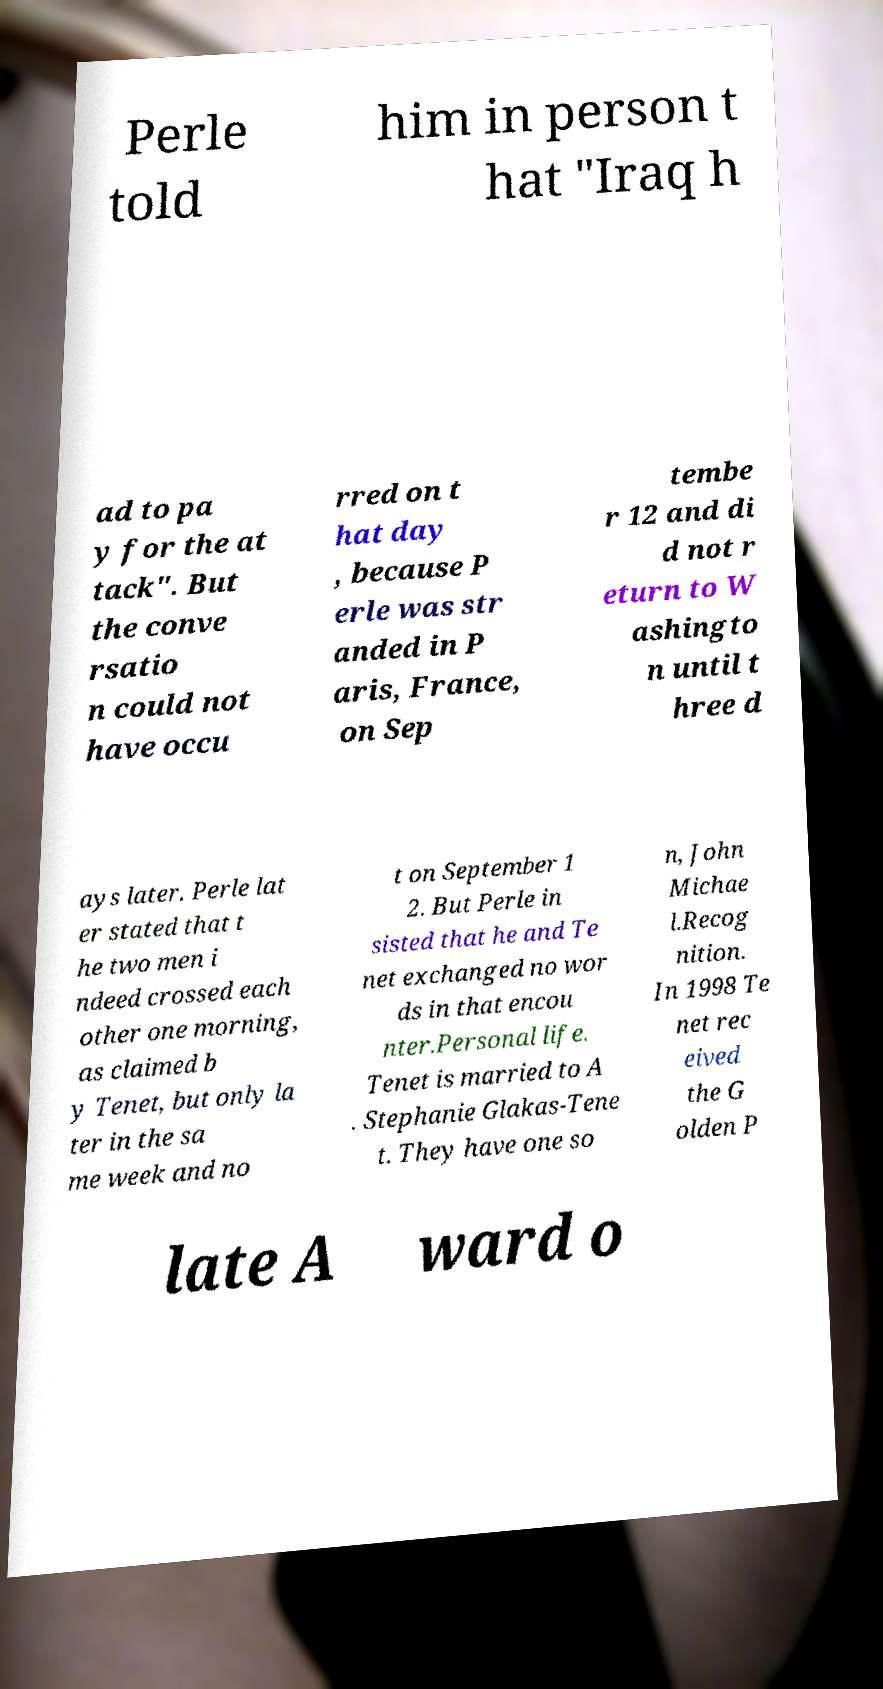Can you read and provide the text displayed in the image?This photo seems to have some interesting text. Can you extract and type it out for me? Perle told him in person t hat "Iraq h ad to pa y for the at tack". But the conve rsatio n could not have occu rred on t hat day , because P erle was str anded in P aris, France, on Sep tembe r 12 and di d not r eturn to W ashingto n until t hree d ays later. Perle lat er stated that t he two men i ndeed crossed each other one morning, as claimed b y Tenet, but only la ter in the sa me week and no t on September 1 2. But Perle in sisted that he and Te net exchanged no wor ds in that encou nter.Personal life. Tenet is married to A . Stephanie Glakas-Tene t. They have one so n, John Michae l.Recog nition. In 1998 Te net rec eived the G olden P late A ward o 